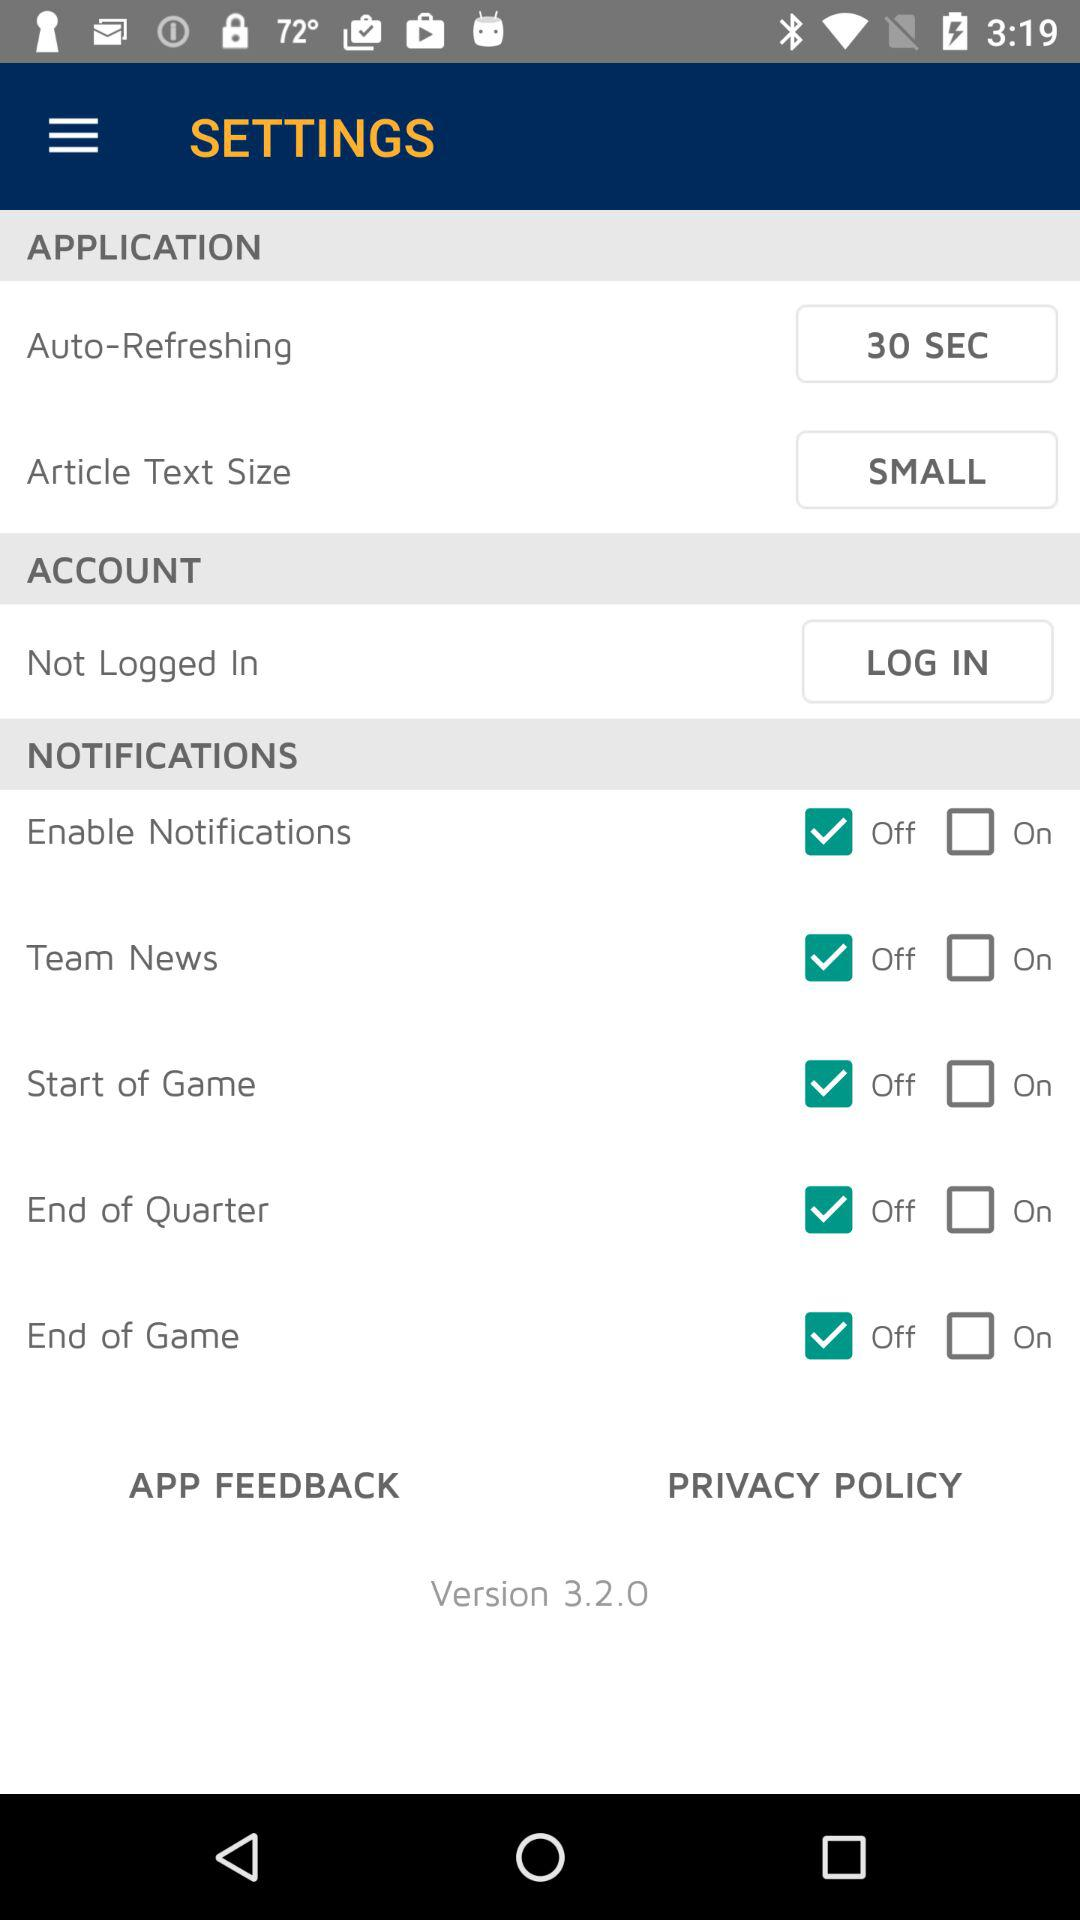Which text sizes are available to the user?
When the provided information is insufficient, respond with <no answer>. <no answer> 